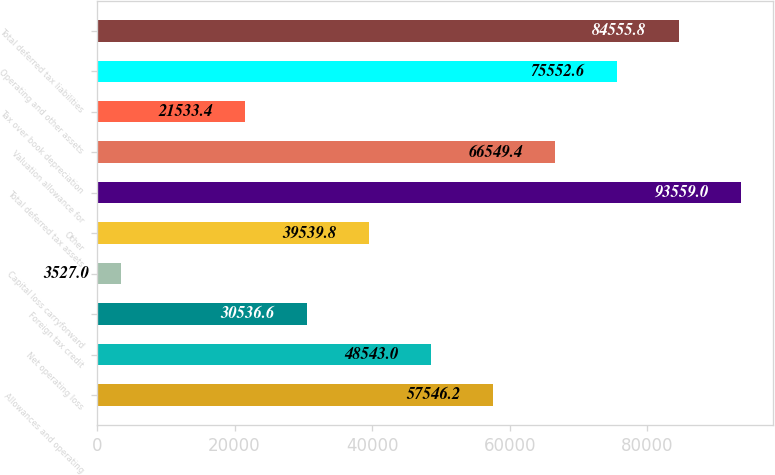Convert chart. <chart><loc_0><loc_0><loc_500><loc_500><bar_chart><fcel>Allowances and operating<fcel>Net operating loss<fcel>Foreign tax credit<fcel>Capital loss carryforward<fcel>Other<fcel>Total deferred tax assets<fcel>Valuation allowance for<fcel>Tax over book depreciation<fcel>Operating and other assets<fcel>Total deferred tax liabilities<nl><fcel>57546.2<fcel>48543<fcel>30536.6<fcel>3527<fcel>39539.8<fcel>93559<fcel>66549.4<fcel>21533.4<fcel>75552.6<fcel>84555.8<nl></chart> 